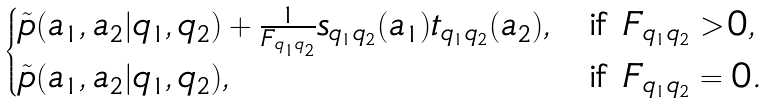Convert formula to latex. <formula><loc_0><loc_0><loc_500><loc_500>\begin{cases} \tilde { p } ( a _ { 1 } , a _ { 2 } | q _ { 1 } , q _ { 2 } ) + \frac { 1 } { F _ { q _ { 1 } q _ { 2 } } } s _ { q _ { 1 } q _ { 2 } } ( a _ { 1 } ) t _ { q _ { 1 } q _ { 2 } } ( a _ { 2 } ) , & \text {if } F _ { q _ { 1 } q _ { 2 } } > 0 , \\ \tilde { p } ( a _ { 1 } , a _ { 2 } | q _ { 1 } , q _ { 2 } ) , & \text {if } F _ { q _ { 1 } q _ { 2 } } = 0 . \end{cases}</formula> 